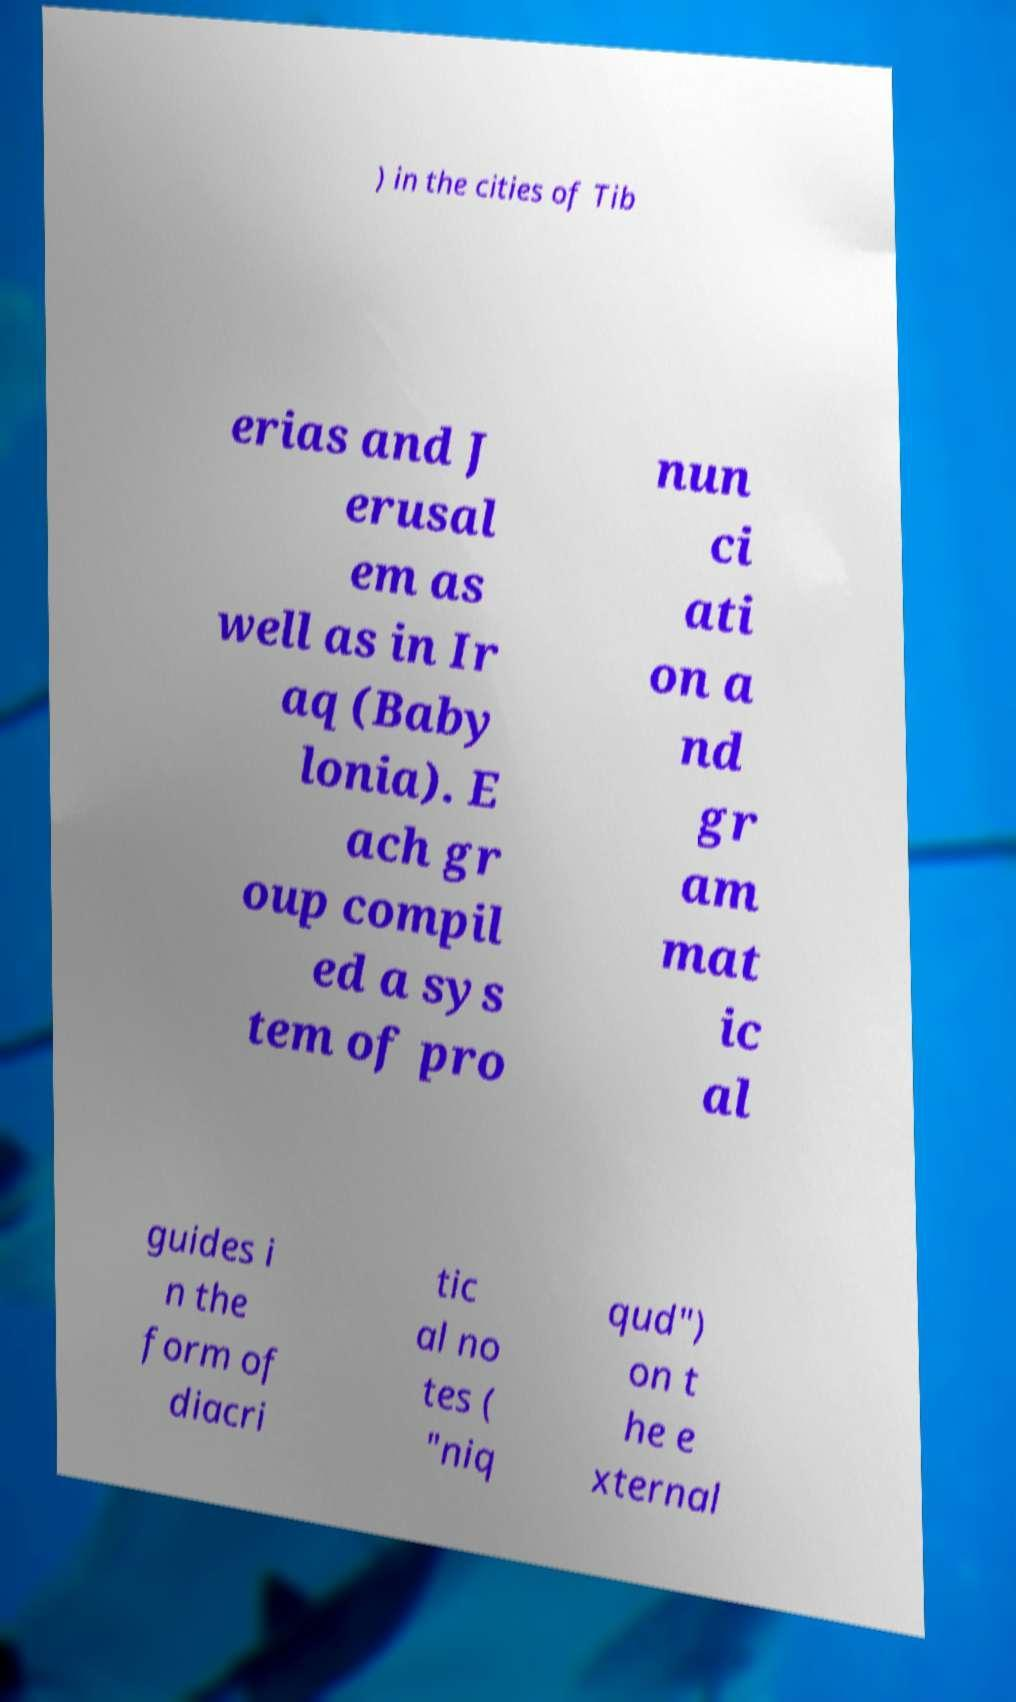Could you extract and type out the text from this image? ) in the cities of Tib erias and J erusal em as well as in Ir aq (Baby lonia). E ach gr oup compil ed a sys tem of pro nun ci ati on a nd gr am mat ic al guides i n the form of diacri tic al no tes ( "niq qud") on t he e xternal 